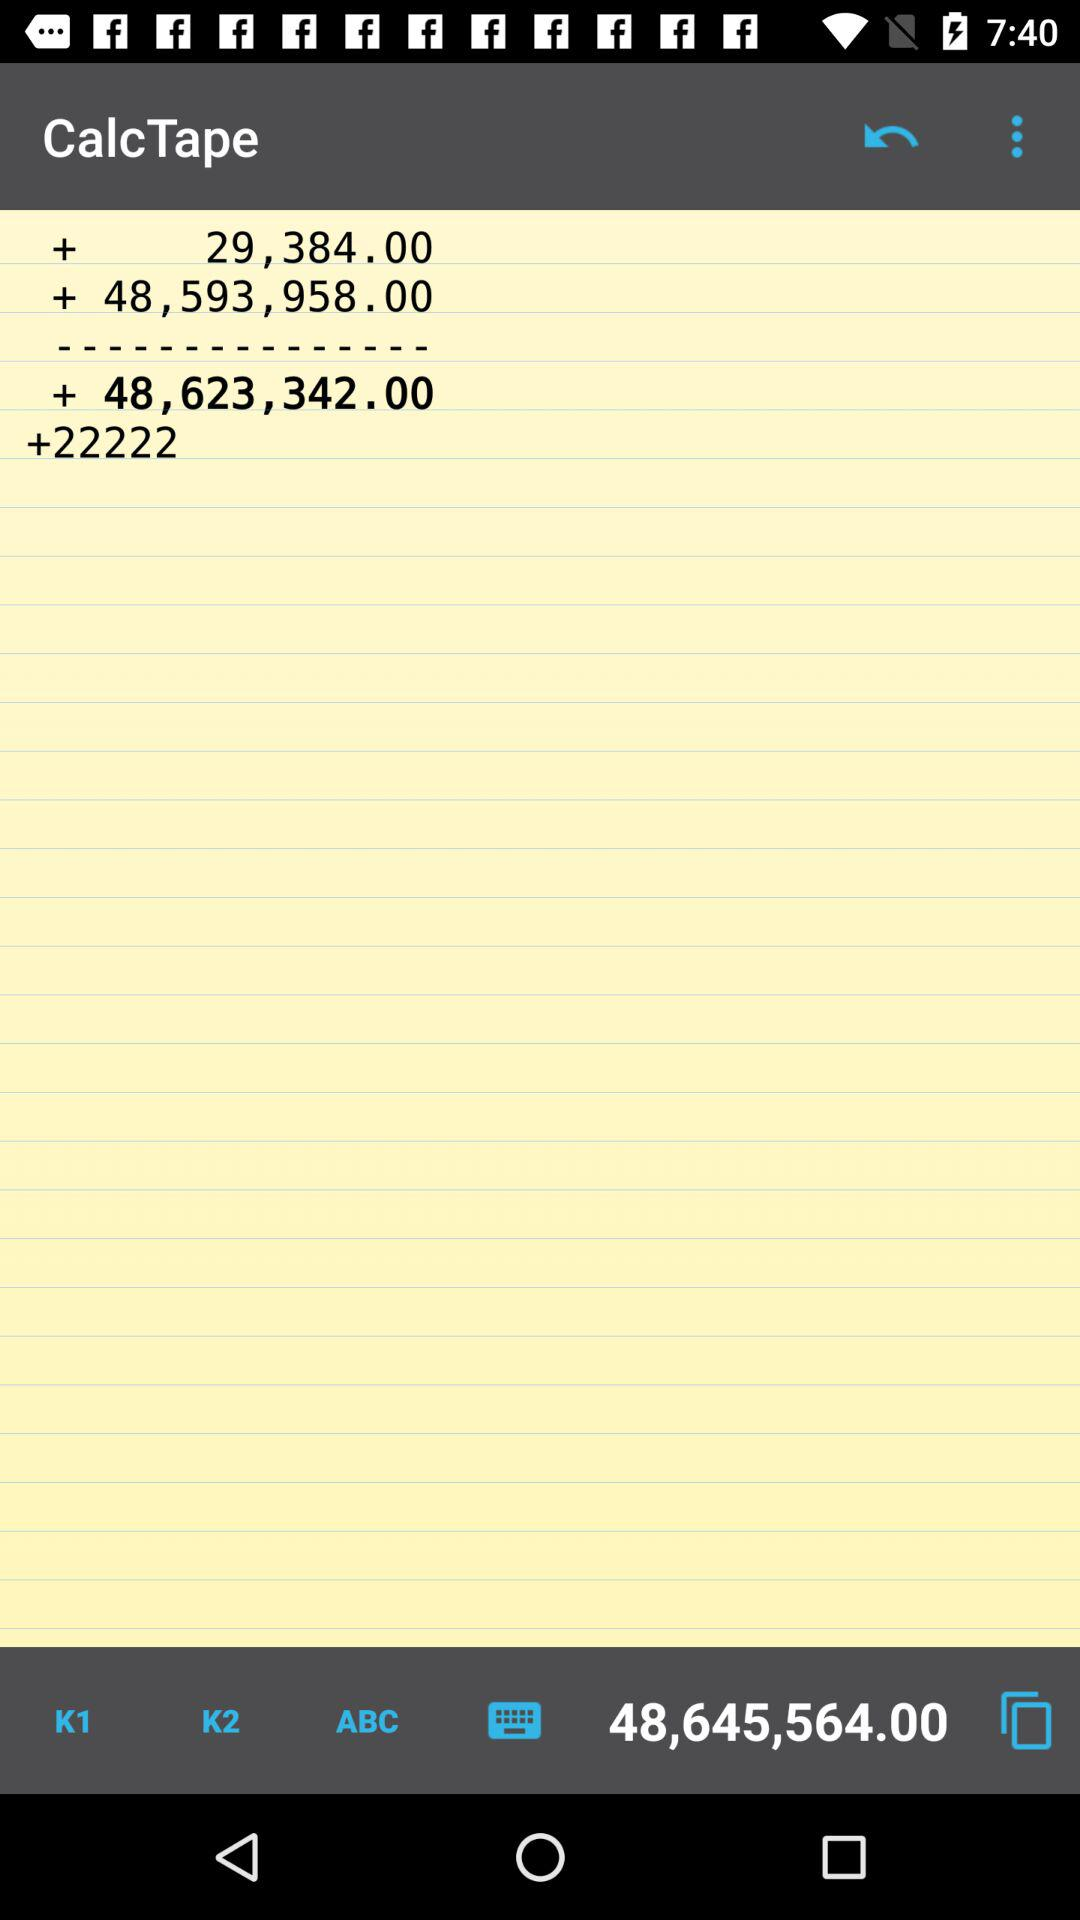What is the application name? The application name is "CalcTape". 